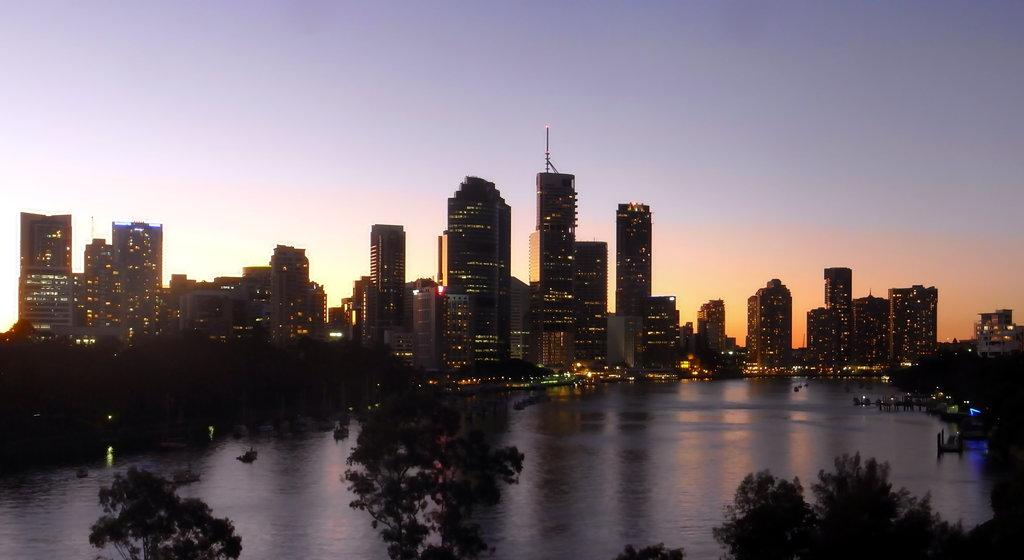What is the primary element visible in the image? There is water in the image. What type of structures can be seen in the background of the image? There are buildings and skyscrapers in the background of the image. What is visible at the top of the image? The sky is visible at the top of the image. What type of vegetation is present at the bottom of the image? Trees are present at the bottom of the image. How many dolls are paying attention to the existence of the water in the image? There are no dolls present in the image, and therefore no dolls can be paying attention to the existence of the water. 